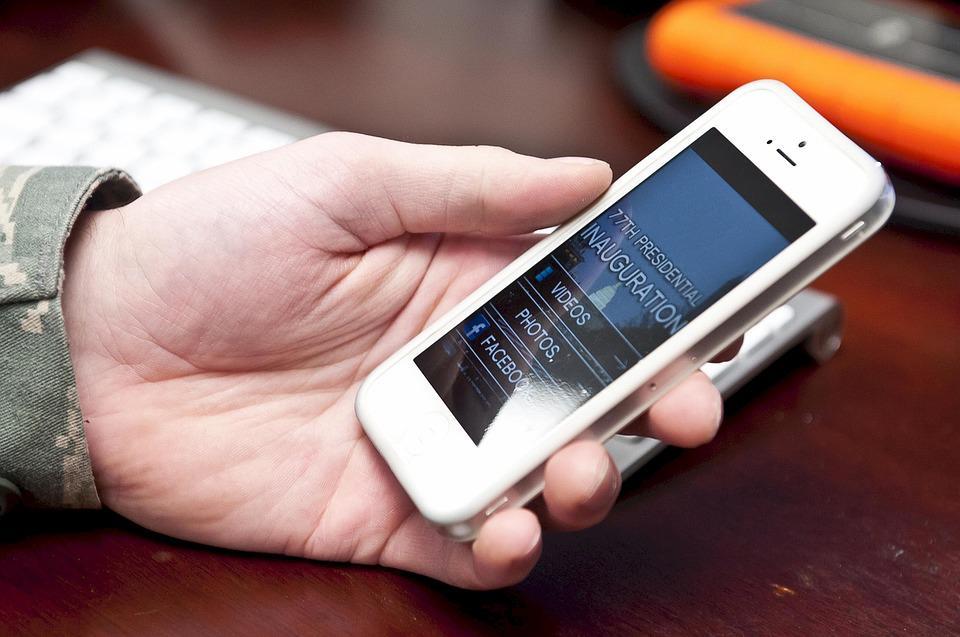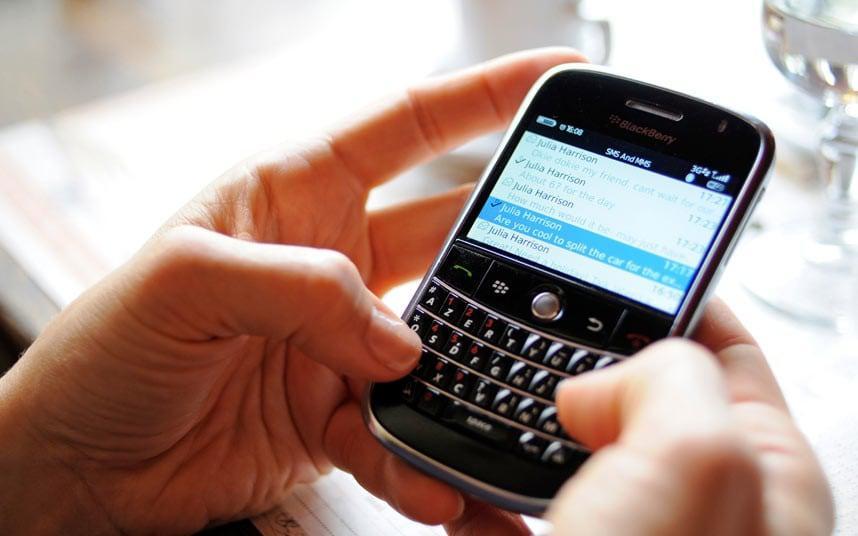The first image is the image on the left, the second image is the image on the right. For the images displayed, is the sentence "In one of the images, a person is typing on a phone with physical keys." factually correct? Answer yes or no. Yes. The first image is the image on the left, the second image is the image on the right. Analyze the images presented: Is the assertion "The phone in the left image is black and the phone in the right image is white." valid? Answer yes or no. No. 